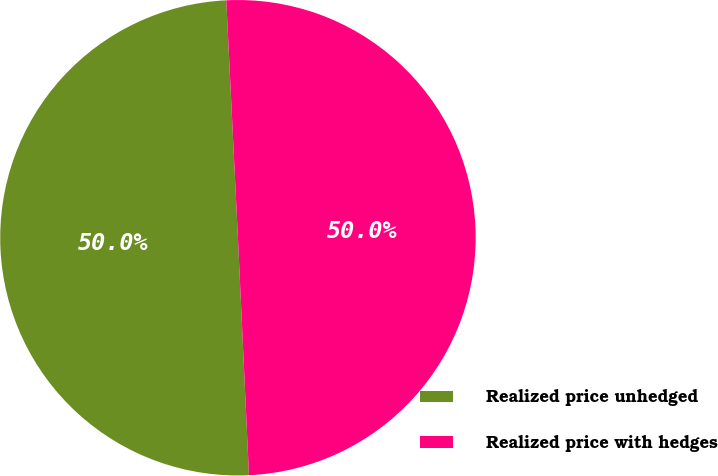Convert chart to OTSL. <chart><loc_0><loc_0><loc_500><loc_500><pie_chart><fcel>Realized price unhedged<fcel>Realized price with hedges<nl><fcel>49.96%<fcel>50.04%<nl></chart> 